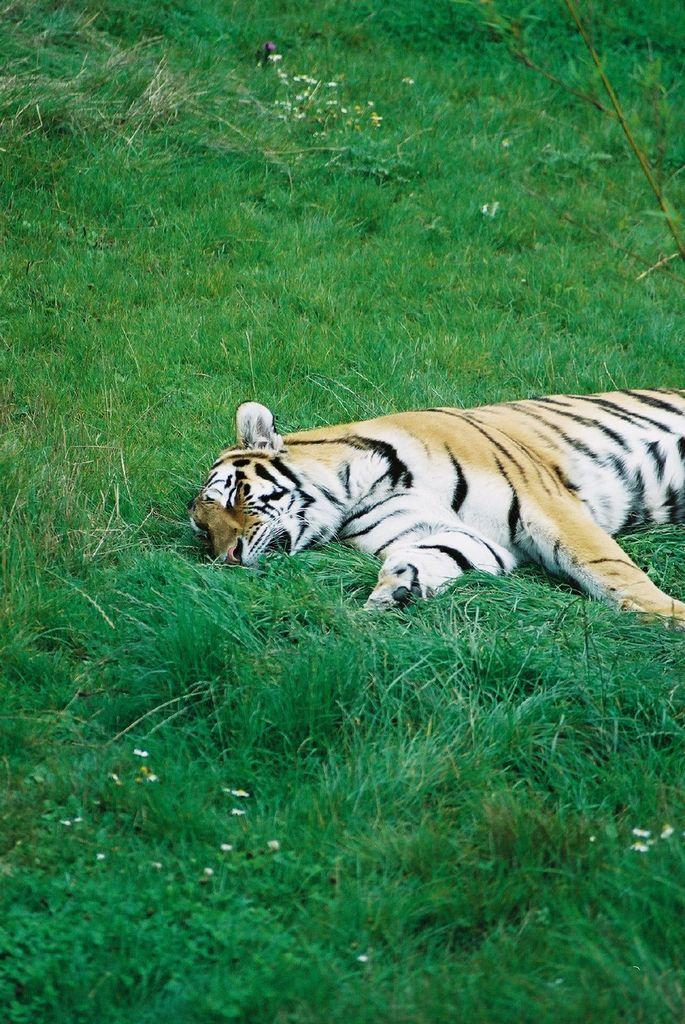What animal is in the picture? There is a tiger in the picture. What is the tiger doing in the picture? The tiger is sleeping. Where is the tiger located in the picture? The tiger is on the grass. What can be seen at the top of the image? There are flowers visible at the top of the image. What type of ink can be seen on the tiger's fur in the image? There is no ink visible on the tiger's fur in the image. How does the doll interact with the tiger in the image? There is no doll present in the image, so it cannot interact with the tiger. 